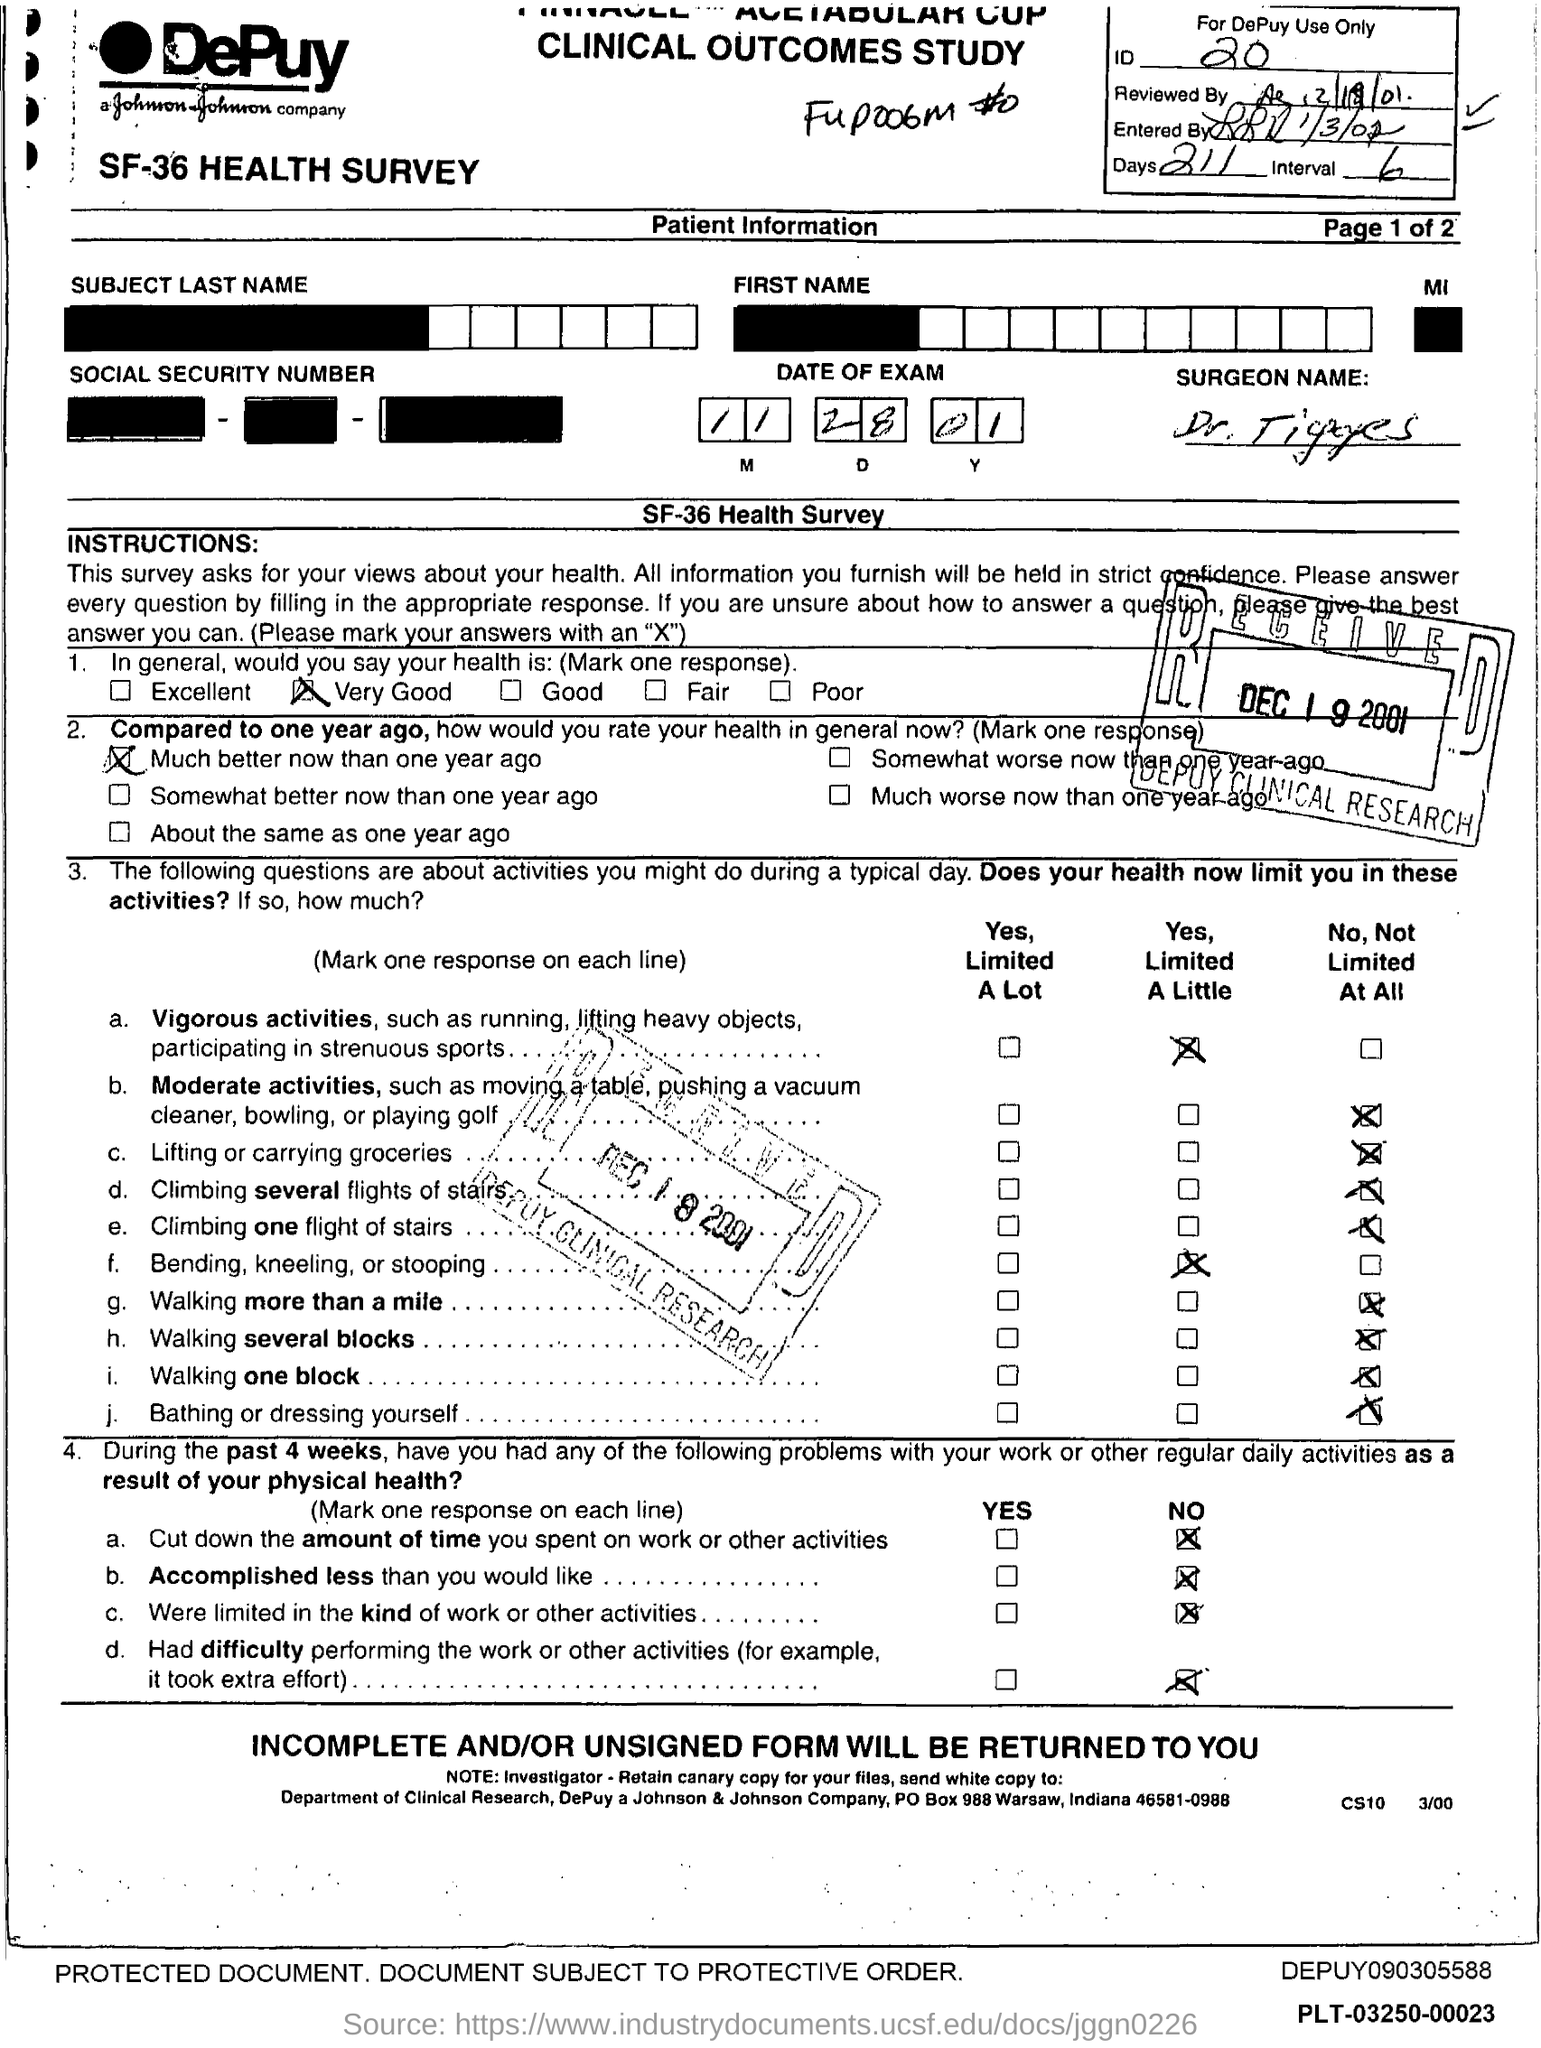What is the ID Number?
Keep it short and to the point. 20. What is the number of days?
Offer a very short reply. 211. 